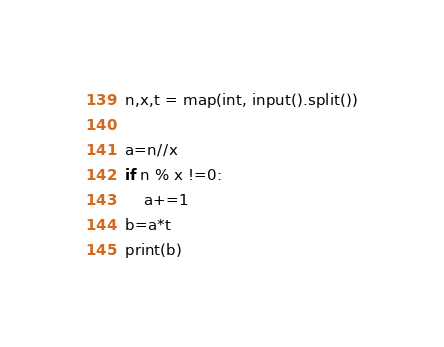Convert code to text. <code><loc_0><loc_0><loc_500><loc_500><_Python_>n,x,t = map(int, input().split())

a=n//x
if n % x !=0:
    a+=1
b=a*t
print(b)</code> 